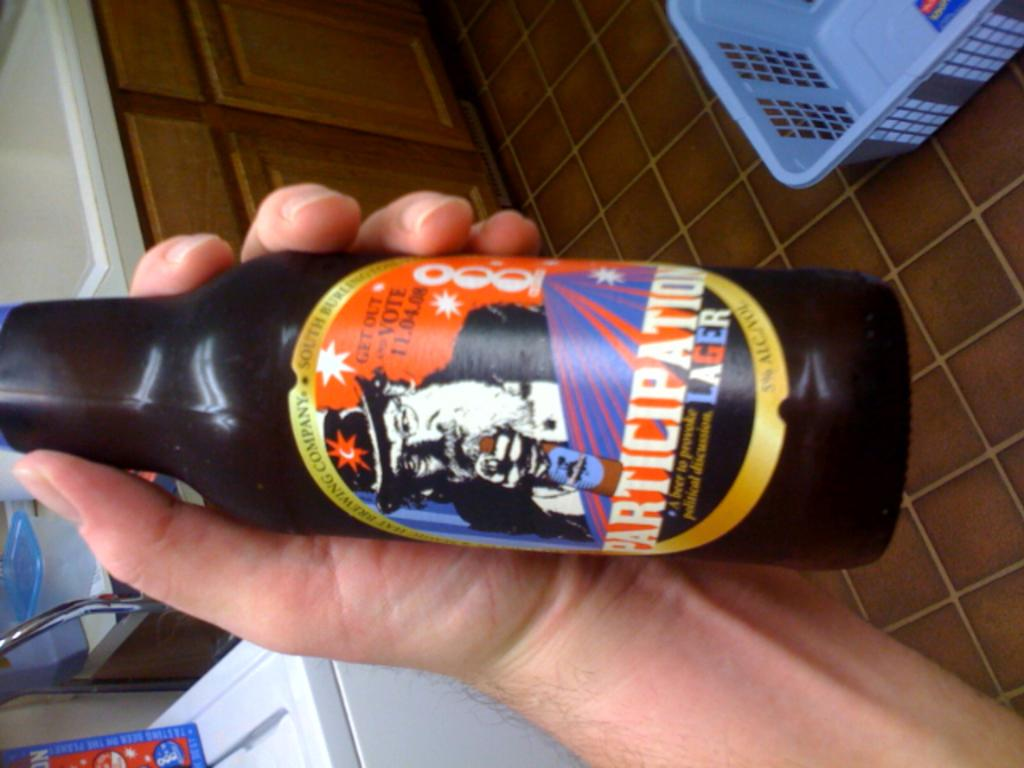Provide a one-sentence caption for the provided image. A picture is rotated 90 degrees left showing a man's hand holding a bottle of Participation Lager. 